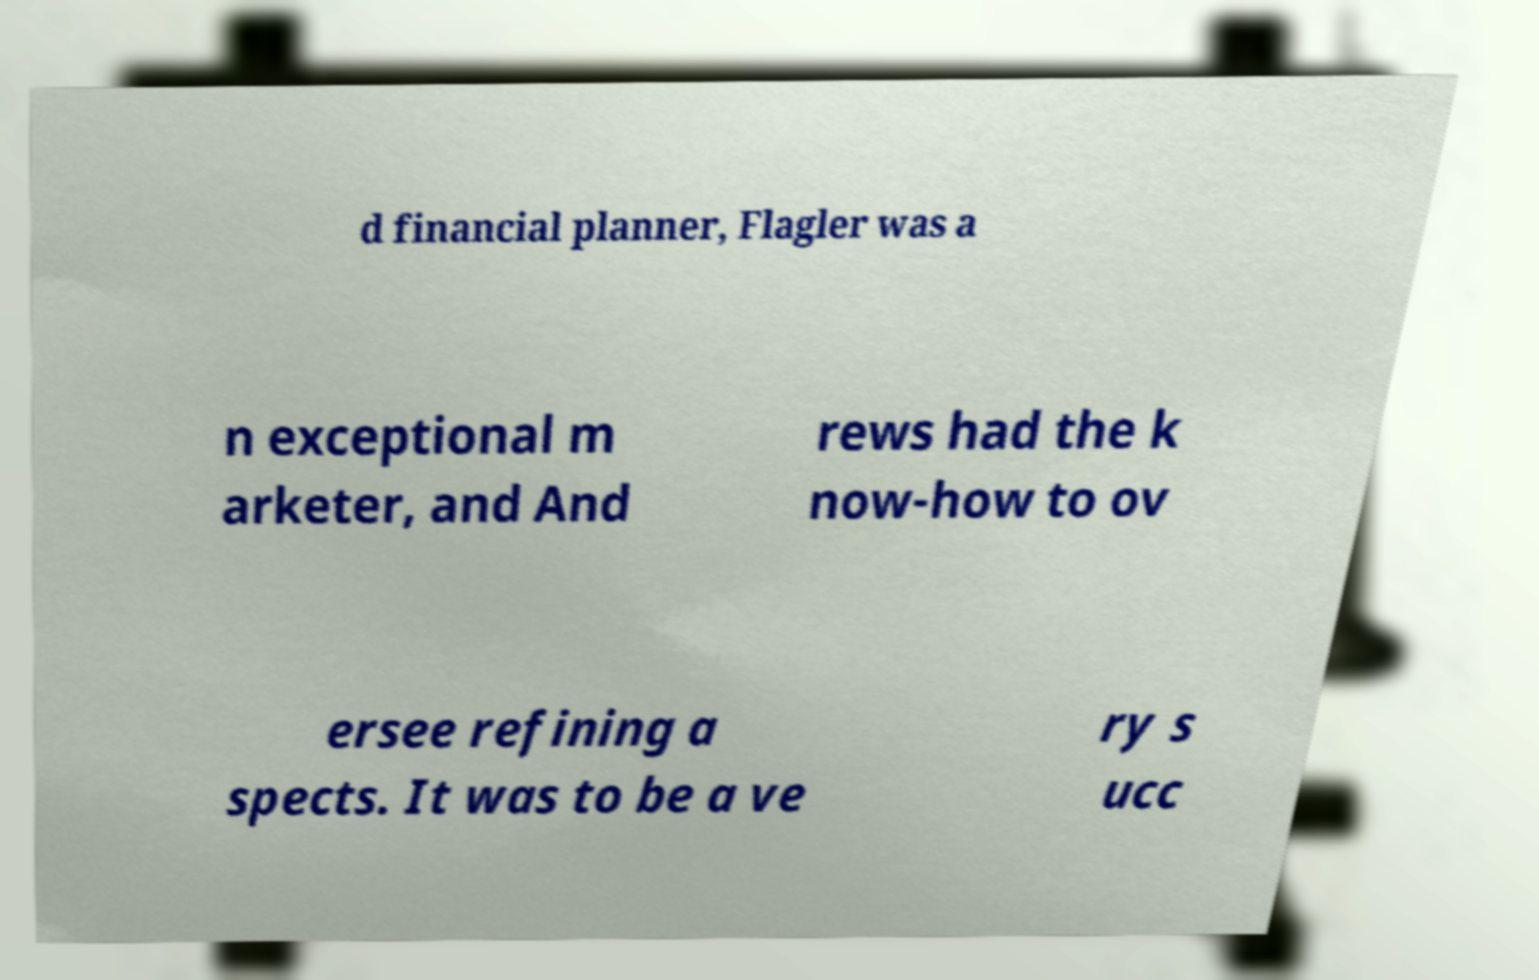Please read and relay the text visible in this image. What does it say? d financial planner, Flagler was a n exceptional m arketer, and And rews had the k now-how to ov ersee refining a spects. It was to be a ve ry s ucc 